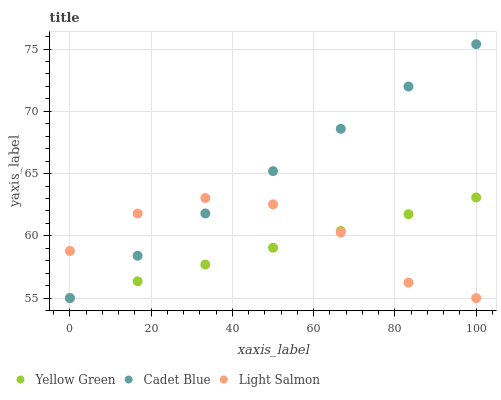Does Yellow Green have the minimum area under the curve?
Answer yes or no. Yes. Does Cadet Blue have the maximum area under the curve?
Answer yes or no. Yes. Does Cadet Blue have the minimum area under the curve?
Answer yes or no. No. Does Yellow Green have the maximum area under the curve?
Answer yes or no. No. Is Yellow Green the smoothest?
Answer yes or no. Yes. Is Light Salmon the roughest?
Answer yes or no. Yes. Is Cadet Blue the smoothest?
Answer yes or no. No. Is Cadet Blue the roughest?
Answer yes or no. No. Does Light Salmon have the lowest value?
Answer yes or no. Yes. Does Cadet Blue have the highest value?
Answer yes or no. Yes. Does Yellow Green have the highest value?
Answer yes or no. No. Does Yellow Green intersect Cadet Blue?
Answer yes or no. Yes. Is Yellow Green less than Cadet Blue?
Answer yes or no. No. Is Yellow Green greater than Cadet Blue?
Answer yes or no. No. 